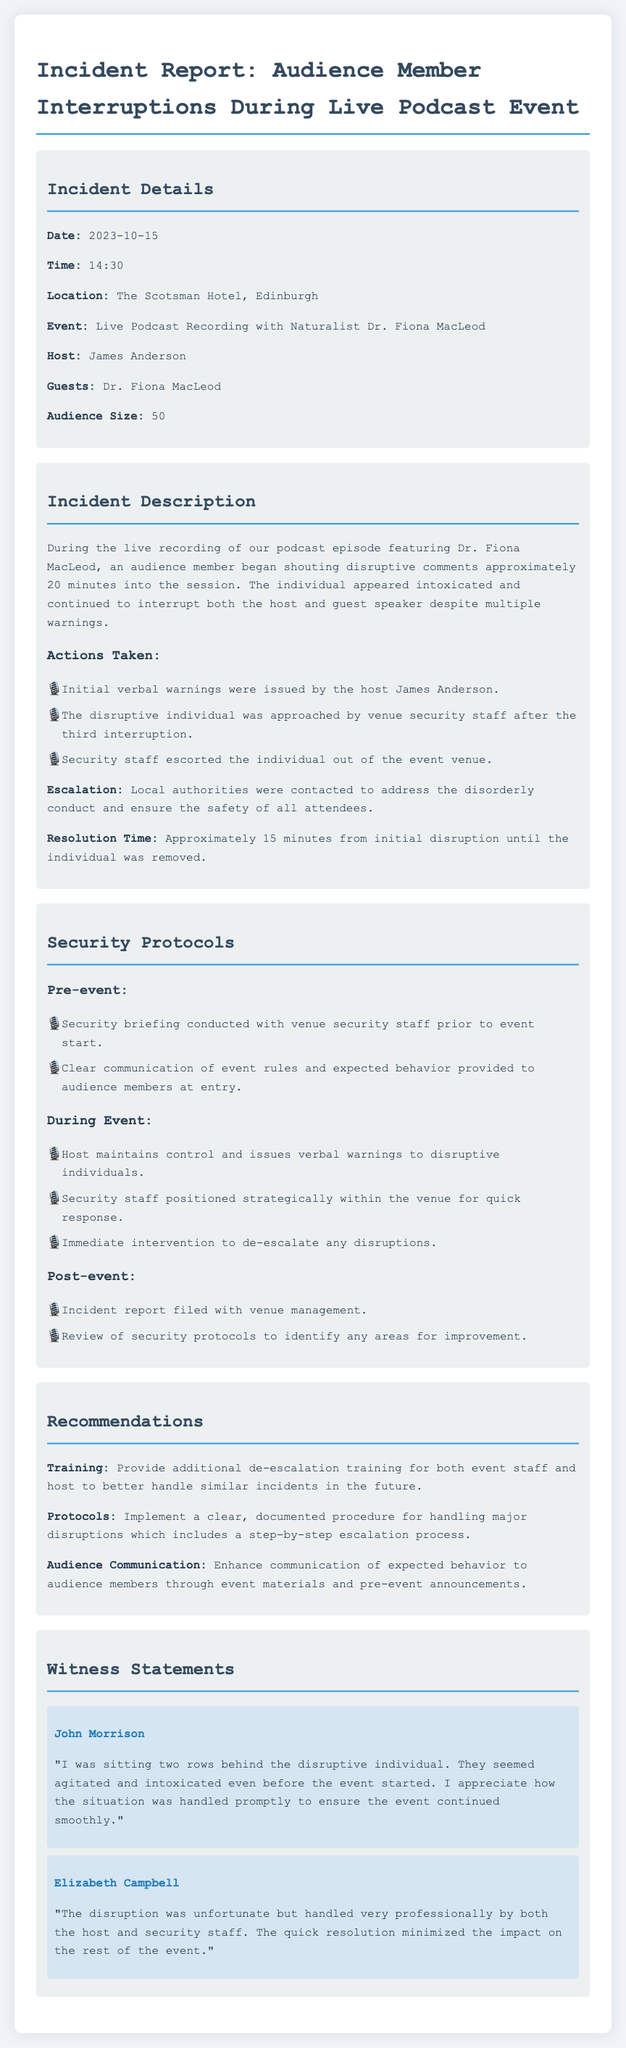What was the date of the incident? The incident date is specified in the document under "Incident Details."
Answer: 2023-10-15 Who was the guest speaker during the event? The guest speaker's name is listed in the "Incident Details" section.
Answer: Dr. Fiona MacLeod How many actions were taken to address the disruption? The number of actions can be counted from the "Actions Taken" list.
Answer: Three What was the location of the live podcast event? The location is provided in the "Incident Details" section.
Answer: The Scotsman Hotel, Edinburgh What type of training is recommended for future events? The recommendation is found under "Recommendations" concerning event staff.
Answer: De-escalation training What time did the incident occur? The time is given in the "Incident Details" section of the report.
Answer: 14:30 What was the audience size during the event? The audience size is detailed in the "Incident Details."
Answer: 50 What did the witness John Morrison comment on? His statement is about the individual's behavior before the event started.
Answer: Agitated and intoxicated What is one of the post-event protocols mentioned? Post-event protocols can be found in the "Security Protocols" section.
Answer: Incident report filed with venue management 